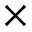<formula> <loc_0><loc_0><loc_500><loc_500>\times</formula> 